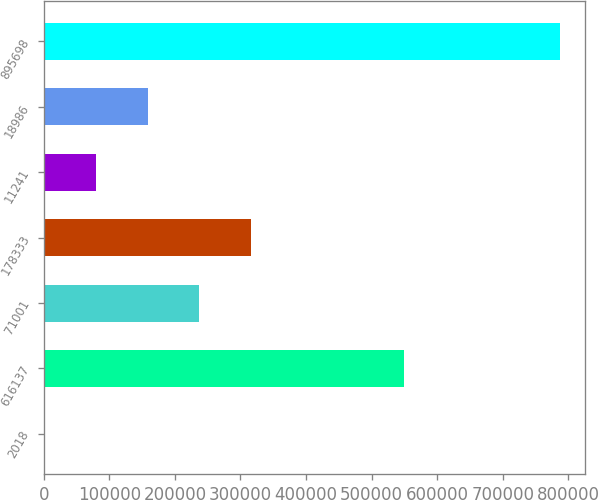Convert chart to OTSL. <chart><loc_0><loc_0><loc_500><loc_500><bar_chart><fcel>2018<fcel>616137<fcel>71001<fcel>178333<fcel>11241<fcel>18986<fcel>895698<nl><fcel>2016<fcel>549552<fcel>237386<fcel>315843<fcel>80472.7<fcel>158929<fcel>786583<nl></chart> 